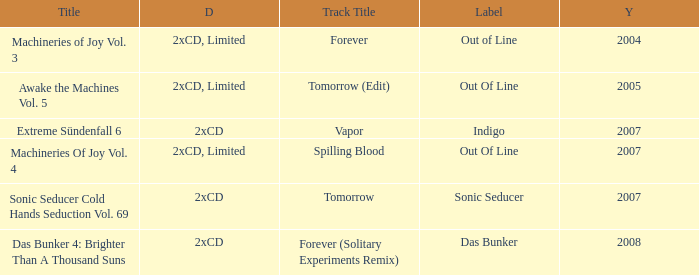What average year contains the title of machineries of joy vol. 4? 2007.0. 